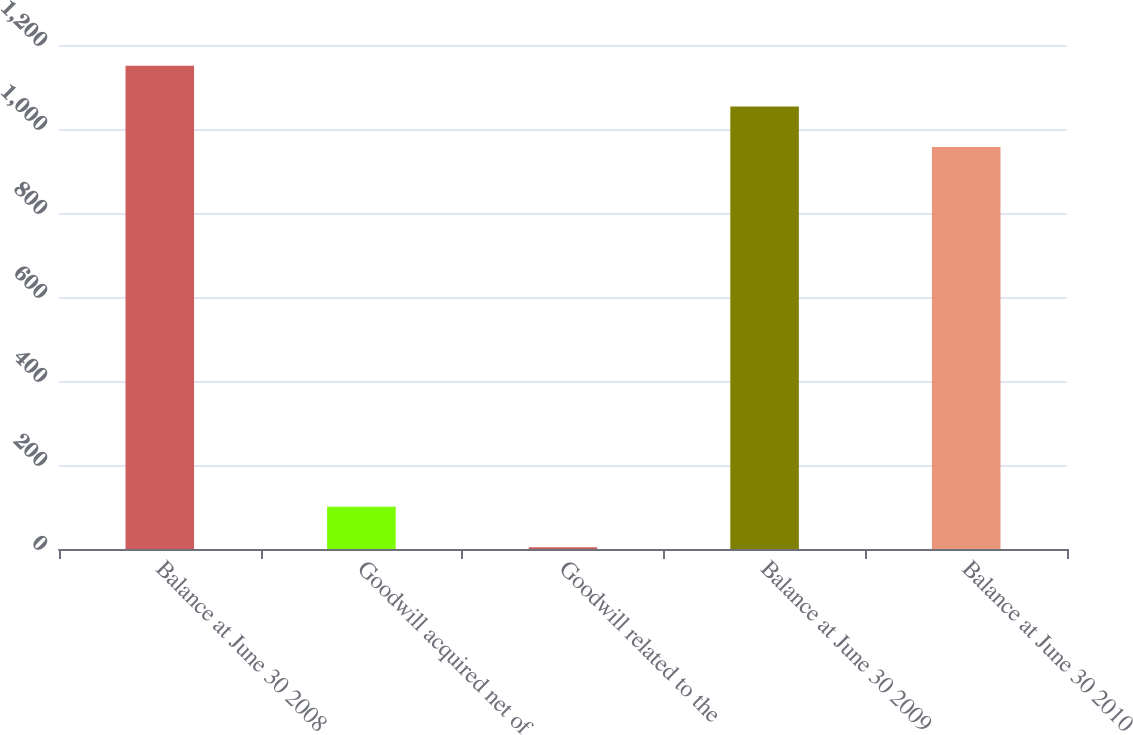Convert chart to OTSL. <chart><loc_0><loc_0><loc_500><loc_500><bar_chart><fcel>Balance at June 30 2008<fcel>Goodwill acquired net of<fcel>Goodwill related to the<fcel>Balance at June 30 2009<fcel>Balance at June 30 2010<nl><fcel>1150.44<fcel>100.7<fcel>3.98<fcel>1053.72<fcel>957<nl></chart> 